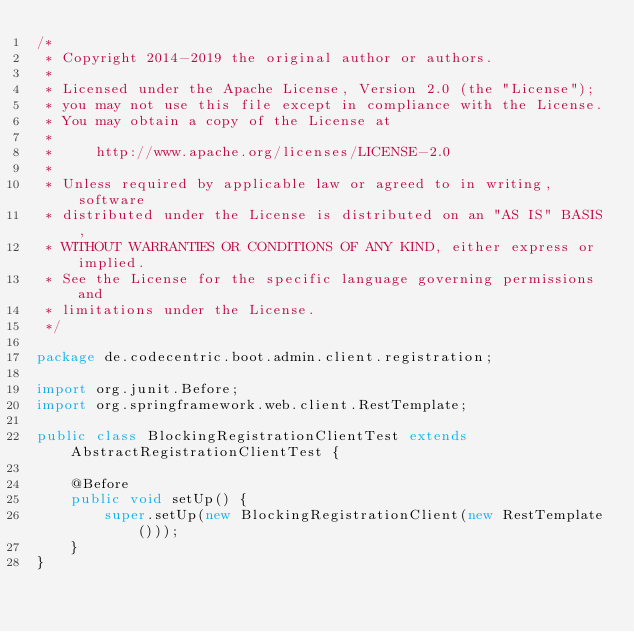<code> <loc_0><loc_0><loc_500><loc_500><_Java_>/*
 * Copyright 2014-2019 the original author or authors.
 *
 * Licensed under the Apache License, Version 2.0 (the "License");
 * you may not use this file except in compliance with the License.
 * You may obtain a copy of the License at
 *
 *     http://www.apache.org/licenses/LICENSE-2.0
 *
 * Unless required by applicable law or agreed to in writing, software
 * distributed under the License is distributed on an "AS IS" BASIS,
 * WITHOUT WARRANTIES OR CONDITIONS OF ANY KIND, either express or implied.
 * See the License for the specific language governing permissions and
 * limitations under the License.
 */

package de.codecentric.boot.admin.client.registration;

import org.junit.Before;
import org.springframework.web.client.RestTemplate;

public class BlockingRegistrationClientTest extends AbstractRegistrationClientTest {

    @Before
    public void setUp() {
        super.setUp(new BlockingRegistrationClient(new RestTemplate()));
    }
}
</code> 